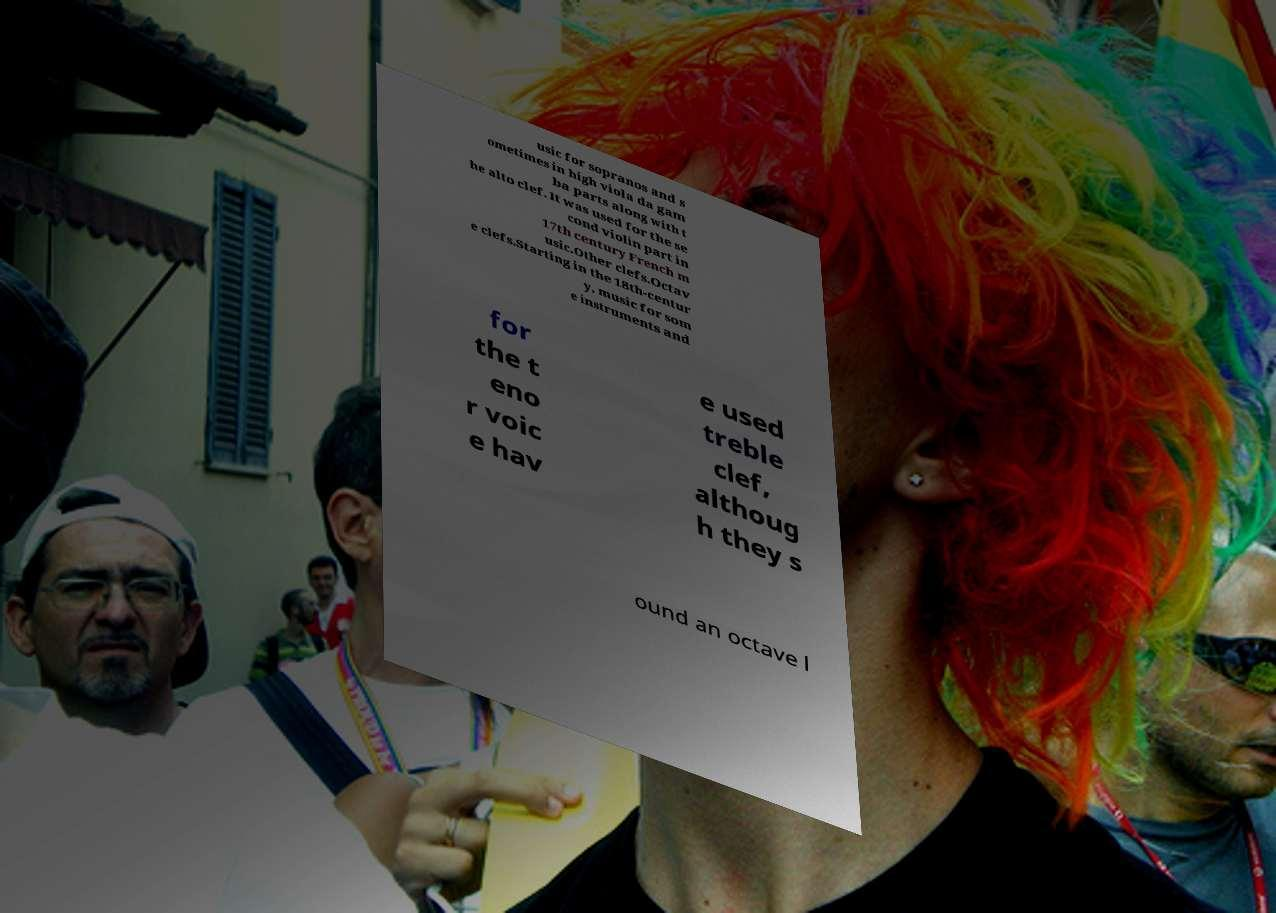Could you extract and type out the text from this image? usic for sopranos and s ometimes in high viola da gam ba parts along with t he alto clef. It was used for the se cond violin part in 17th century French m usic.Other clefs.Octav e clefs.Starting in the 18th-centur y, music for som e instruments and for the t eno r voic e hav e used treble clef, althoug h they s ound an octave l 